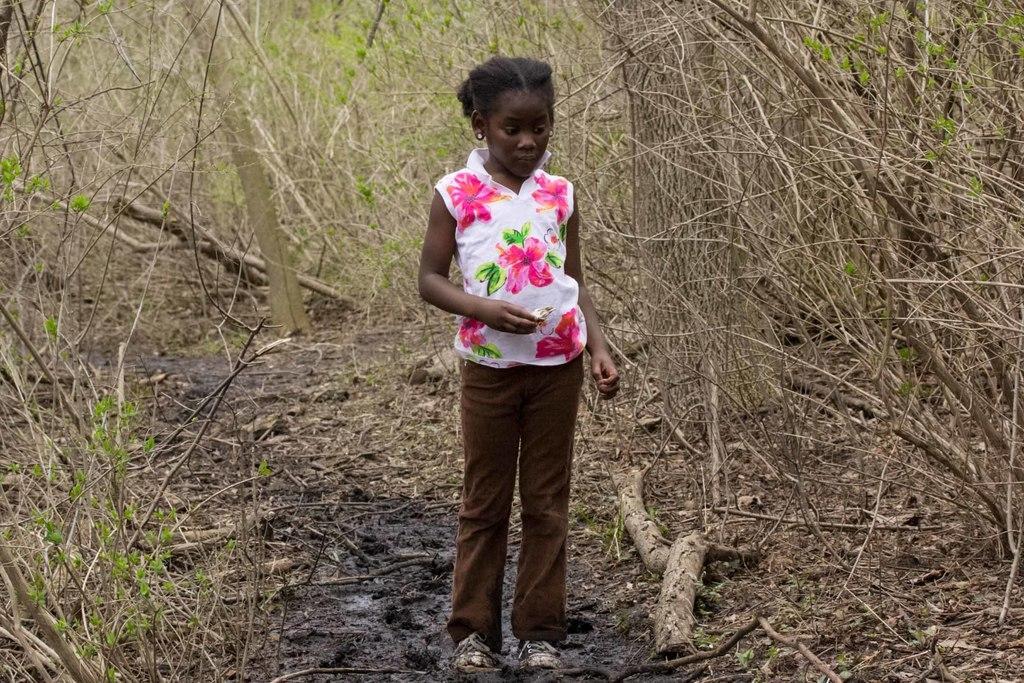Describe this image in one or two sentences. In this image we can see a child standing on the ground and holding an object and there are few trees in the background. 